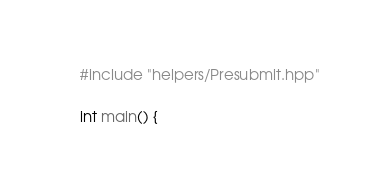Convert code to text. <code><loc_0><loc_0><loc_500><loc_500><_C++_>#include "helpers/Presubmit.hpp"

int main() {</code> 